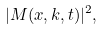<formula> <loc_0><loc_0><loc_500><loc_500>| M ( x , k , t ) | ^ { 2 } ,</formula> 